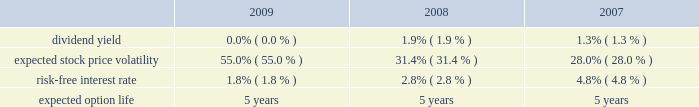Royal caribbean cruises ltd .
Notes to the consolidated financial statements 2014 ( continued ) note 9 .
Stock-based employee compensation we have four stock-based compensation plans , which provide for awards to our officers , directors and key employees .
The plans consist of a 1990 employee stock option plan , a 1995 incentive stock option plan , a 2000 stock award plan , and a 2008 equity plan .
The 1990 stock option plan and the 1995 incentive stock option plan terminated by their terms in march 2000 and february 2005 , respectively .
The 2000 stock award plan , as amended , and the 2008 equity plan provide for the issuance of ( i ) incentive and non-qualified stock options , ( ii ) stock appreciation rights , ( iii ) restricted stock , ( iv ) restricted stock units and ( v ) up to 13000000 performance shares of our common stock for the 2000 stock award plan and up to 5000000 performance shares of our common stock for the 2008 equity plan .
During any calendar year , no one individual shall be granted awards of more than 500000 shares .
Options and restricted stock units outstanding as of december 31 , 2009 vest in equal installments over four to five years from the date of grant .
Generally , options and restricted stock units are forfeited if the recipient ceases to be a director or employee before the shares vest .
Options are granted at a price not less than the fair value of the shares on the date of grant and expire not later than ten years after the date of grant .
We also provide an employee stock purchase plan to facilitate the purchase by employees of up to 800000 shares of common stock in the aggregate .
Offerings to employees are made on a quarterly basis .
Subject to certain limitations , the purchase price for each share of common stock is equal to 90% ( 90 % ) of the average of the market prices of the common stock as reported on the new york stock exchange on the first business day of the purchase period and the last business day of each month of the purchase period .
Shares of common stock of 65005 , 36836 and 20759 were issued under the espp at a weighted-average price of $ 12.78 , $ 20.97 and $ 37.25 during 2009 , 2008 and 2007 , respectively .
Under the chief executive officer 2019s employment agreement we contributed 10086 shares of our common stock quarterly , to a maximum of 806880 shares , to a trust on his behalf .
In january 2009 , the employment agreement and related trust agreement were amended .
Consequently , 768018 shares were distributed from the trust and future quarterly share distributions are issued directly to the chief executive officer .
Total compensation expenses recognized for employee stock-based compensation for the year ended december 31 , 2009 was $ 16.8 million .
Of this amount , $ 16.2 million was included within marketing , selling and administrative expenses and $ 0.6 million was included within payroll and related expenses .
Total compensation expense recognized for employee stock-based compensation for the year ended december 31 , 2008 was $ 5.7 million .
Of this amount , $ 6.4 million , which included a benefit of approximately $ 8.2 million due to a change in the employee forfeiture rate assumption was included within marketing , selling and administrative expenses and income of $ 0.7 million was included within payroll and related expenses which also included a benefit of approximately $ 1.0 million due to the change in the forfeiture rate .
Total compensation expenses recognized for employee stock-based compensation for the year ended december 31 , 2007 was $ 19.0 million .
Of this amount , $ 16.3 million was included within marketing , selling and administrative expenses and $ 2.7 million was included within payroll and related expenses .
The fair value of each stock option grant is estimated on the date of grant using the black-scholes option pricing model .
The estimated fair value of stock options , less estimated forfeitures , is amortized over the vesting period using the graded-vesting method .
The assumptions used in the black-scholes option-pricing model are as follows : expected volatility was based on a combination of historical and implied volatilities .
The risk-free interest rate is based on united states treasury zero coupon issues with a remaining term equal to the expected option life assumed at the date of grant .
The expected term was calculated based on historical experience and represents the time period options actually remain outstanding .
We estimate forfeitures based on historical pre-vesting forfeiture rates and revise those estimates as appropriate to reflect actual experience .
In 2008 , we increased our estimated forfeiture rate from 4% ( 4 % ) for options and 8.5% ( 8.5 % ) for restricted stock units to 20% ( 20 % ) to reflect changes in employee retention rates. .

What was the total value of all shares of common stock were issued under the espp from 2007-2009?[14] : shares of common stock of 65005 , 36836 and 20759 were issued under the espp at a weighted-average price of $ 12.78 , $ 20.97 and $ 37.25 during 2009 , 2008 and 2007 , respectively .? 
Computations: (((65005 * 12.78) + (36836 * 20.97)) + (20759 * 37.25))
Answer: 2376487.57. 